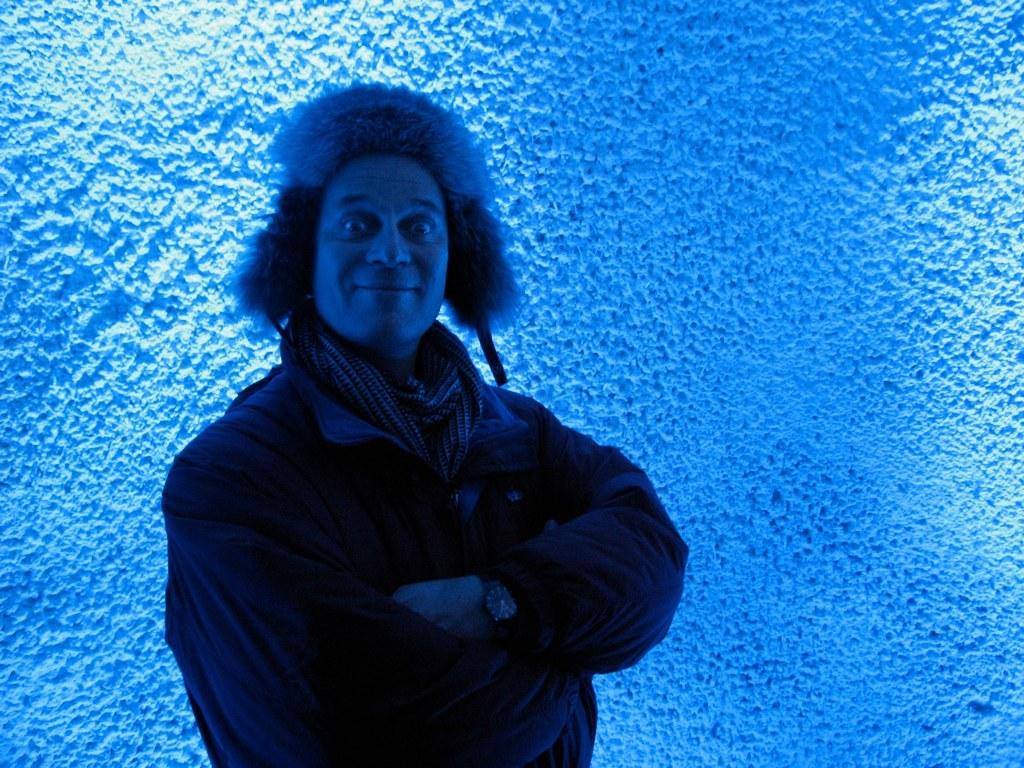What is present in the image? There is a man in the image. What is the man doing in the image? The man is standing in the image. What is the man's facial expression in the image? The man is smiling in the image. What can be seen in the background of the image? There is a wall in the background of the image. Where is the tin located in the image? There is no tin present in the image. What type of doctor is standing next to the man in the image? There is no doctor present in the image. 